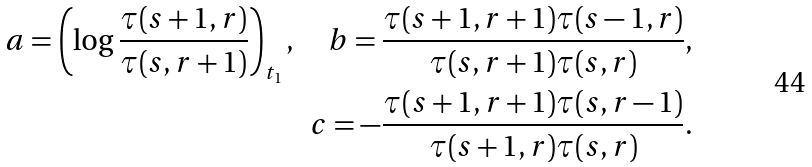<formula> <loc_0><loc_0><loc_500><loc_500>a = \left ( \log \frac { \tau ( s + 1 , r ) } { \tau ( s , r + 1 ) } \right ) _ { t _ { 1 } } , \quad b = \frac { \tau ( s + 1 , r + 1 ) \tau ( s - 1 , r ) } { \tau ( s , r + 1 ) \tau ( s , r ) } , \\ c = - \frac { \tau ( s + 1 , r + 1 ) \tau ( s , r - 1 ) } { \tau ( s + 1 , r ) \tau ( s , r ) } .</formula> 